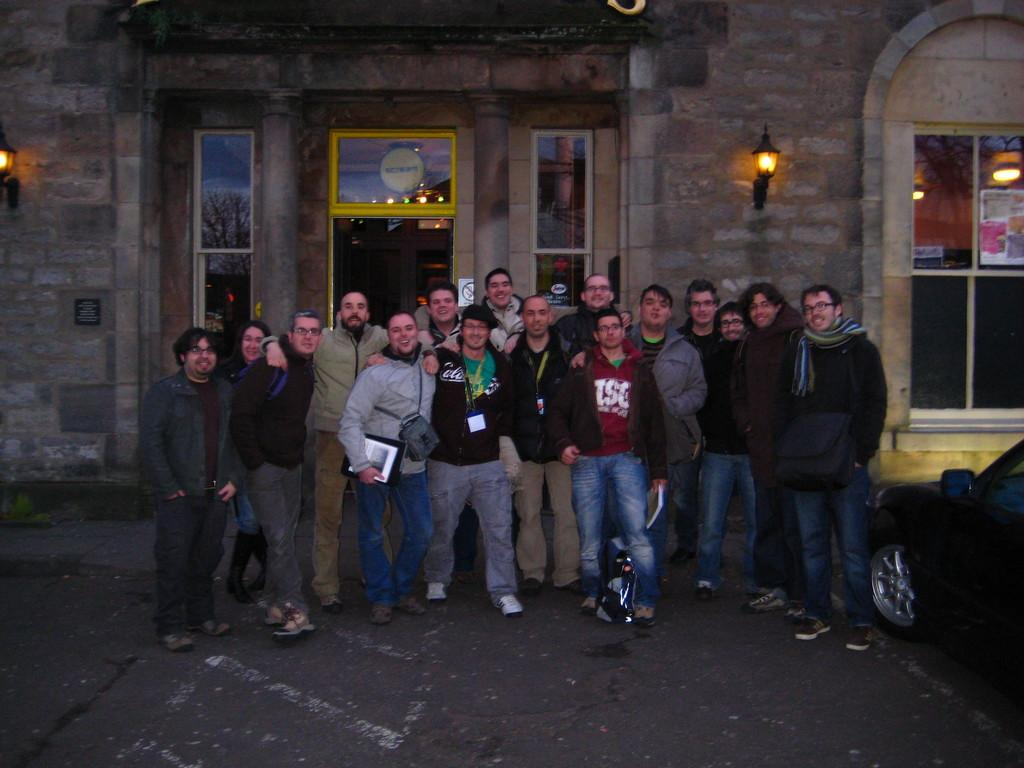What is happening in the image involving a group of people? There is a group of people standing in the image. What are the people holding in the image? The people are holding objects. What are the people wearing in the image? The people are wearing bags. What can be seen in the background of the image? There is a building with windows in the background of the image. What is the father doing in the image? There is no specific reference to a father in the image, so it is not possible to answer that question. 